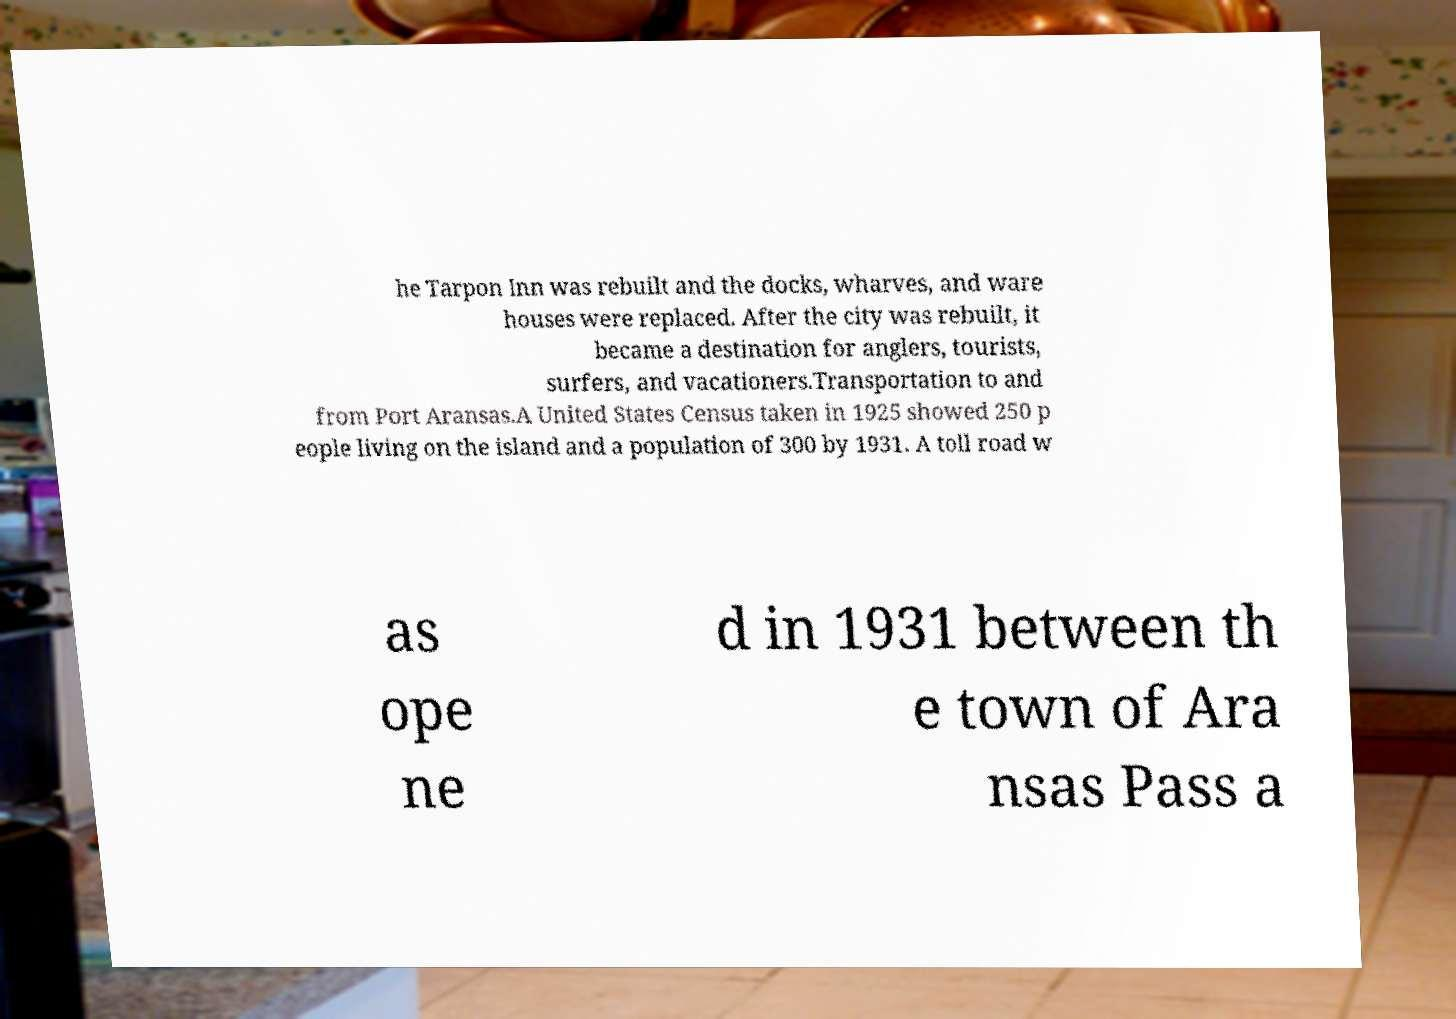I need the written content from this picture converted into text. Can you do that? he Tarpon Inn was rebuilt and the docks, wharves, and ware houses were replaced. After the city was rebuilt, it became a destination for anglers, tourists, surfers, and vacationers.Transportation to and from Port Aransas.A United States Census taken in 1925 showed 250 p eople living on the island and a population of 300 by 1931. A toll road w as ope ne d in 1931 between th e town of Ara nsas Pass a 